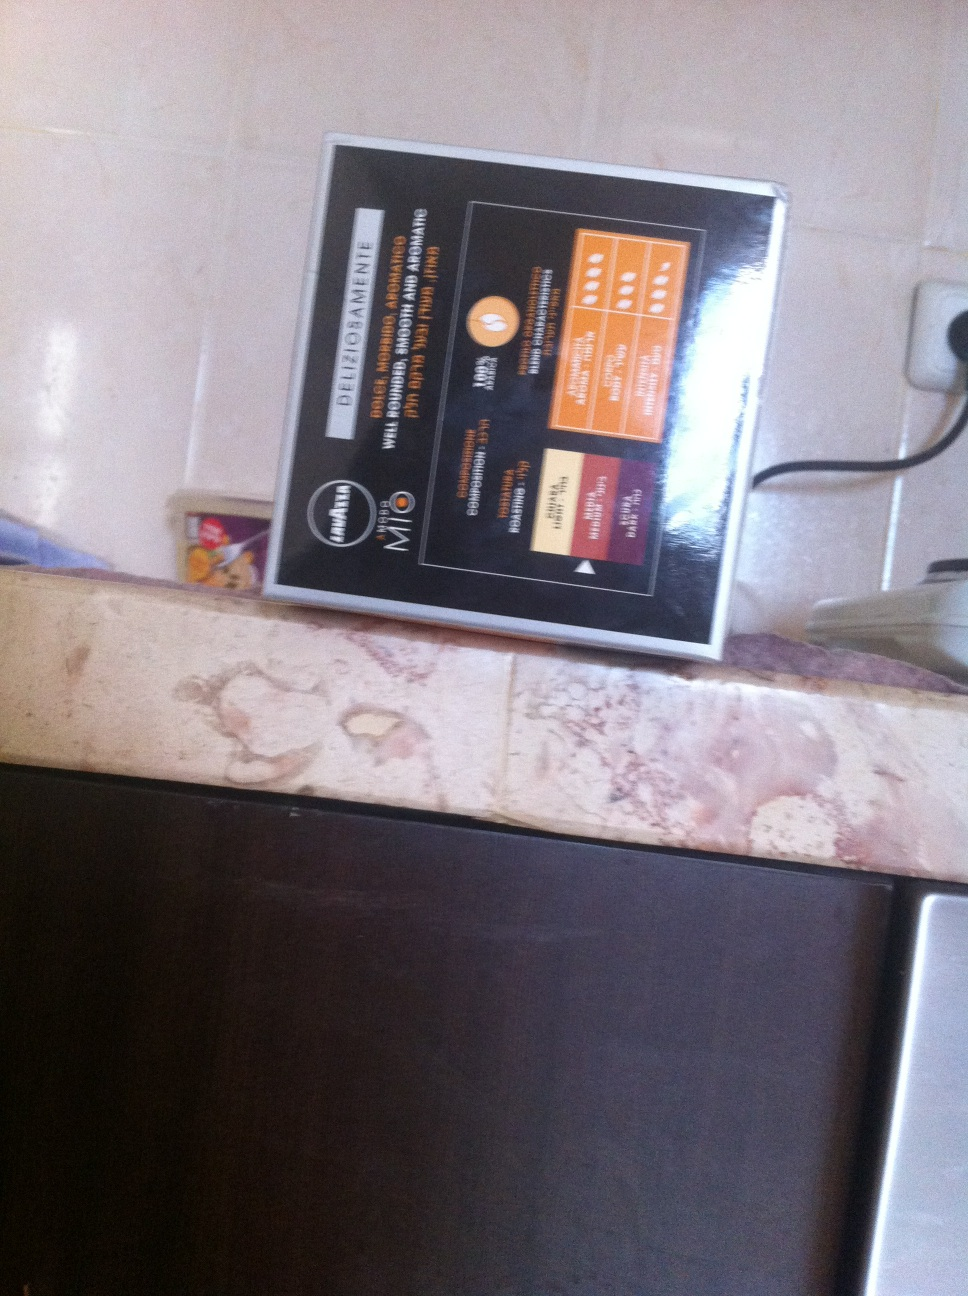How could someone use this guide in their daily life? This guide could prove extremely useful for individuals looking to manage or adjust their diet according to specific health needs. By following the tips, one could tailor their food choices and portion sizes to improve overall health or address conditions like diabetes or heart disease. Placing it in a common area like a kitchen can remind users regularly about their dietary goals. 